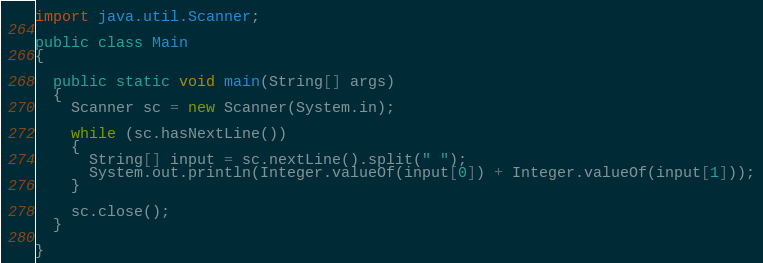<code> <loc_0><loc_0><loc_500><loc_500><_Java_>import java.util.Scanner;

public class Main
{

  public static void main(String[] args)
  {
    Scanner sc = new Scanner(System.in);

    while (sc.hasNextLine())
    {
      String[] input = sc.nextLine().split(" ");
      System.out.println(Integer.valueOf(input[0]) + Integer.valueOf(input[1]));
    }

    sc.close();
  }

}

</code> 